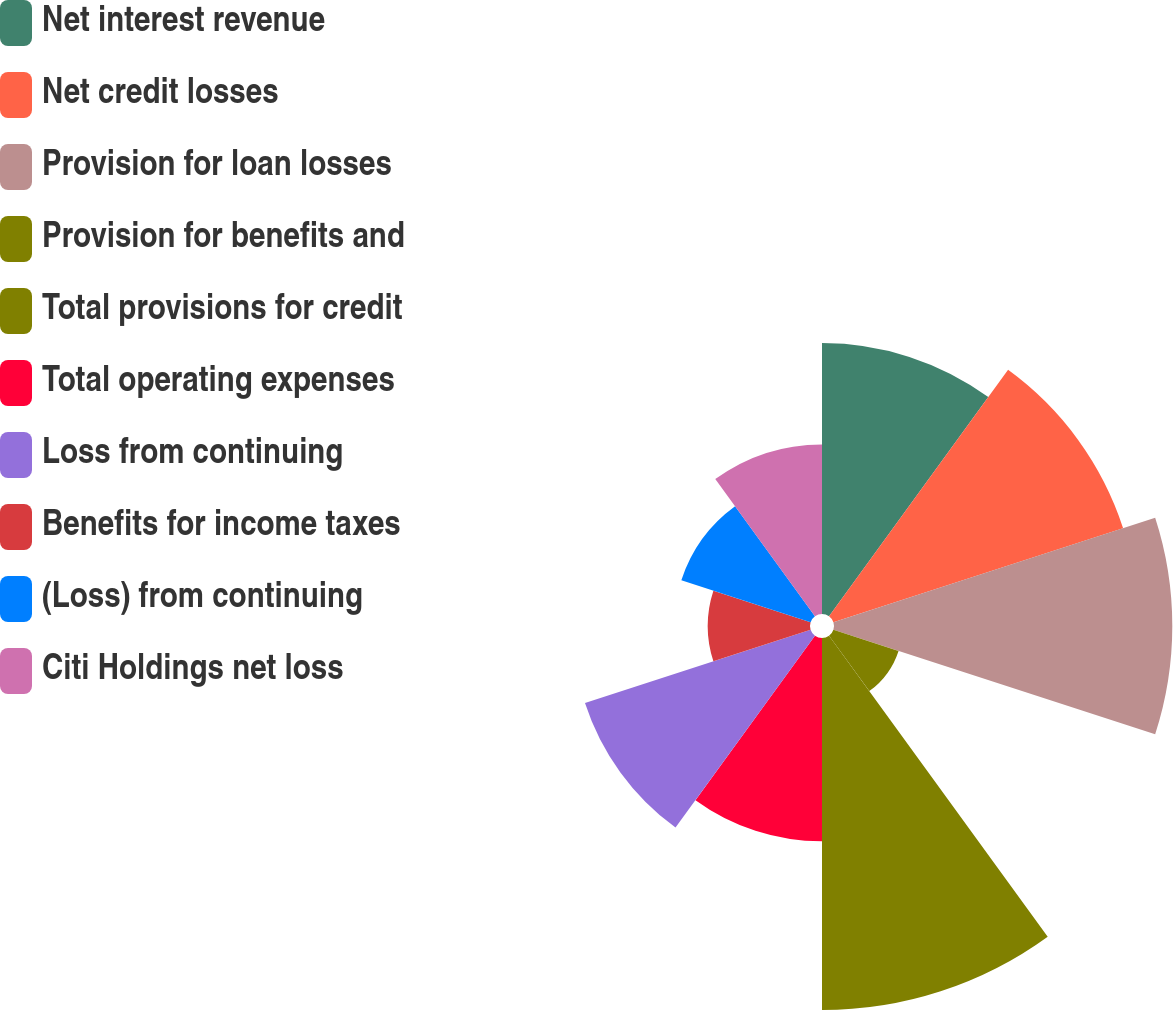Convert chart. <chart><loc_0><loc_0><loc_500><loc_500><pie_chart><fcel>Net interest revenue<fcel>Net credit losses<fcel>Provision for loan losses<fcel>Provision for benefits and<fcel>Total provisions for credit<fcel>Total operating expenses<fcel>Loss from continuing<fcel>Benefits for income taxes<fcel>(Loss) from continuing<fcel>Citi Holdings net loss<nl><fcel>12.3%<fcel>13.83%<fcel>15.36%<fcel>3.11%<fcel>16.89%<fcel>9.23%<fcel>10.77%<fcel>4.64%<fcel>6.17%<fcel>7.7%<nl></chart> 